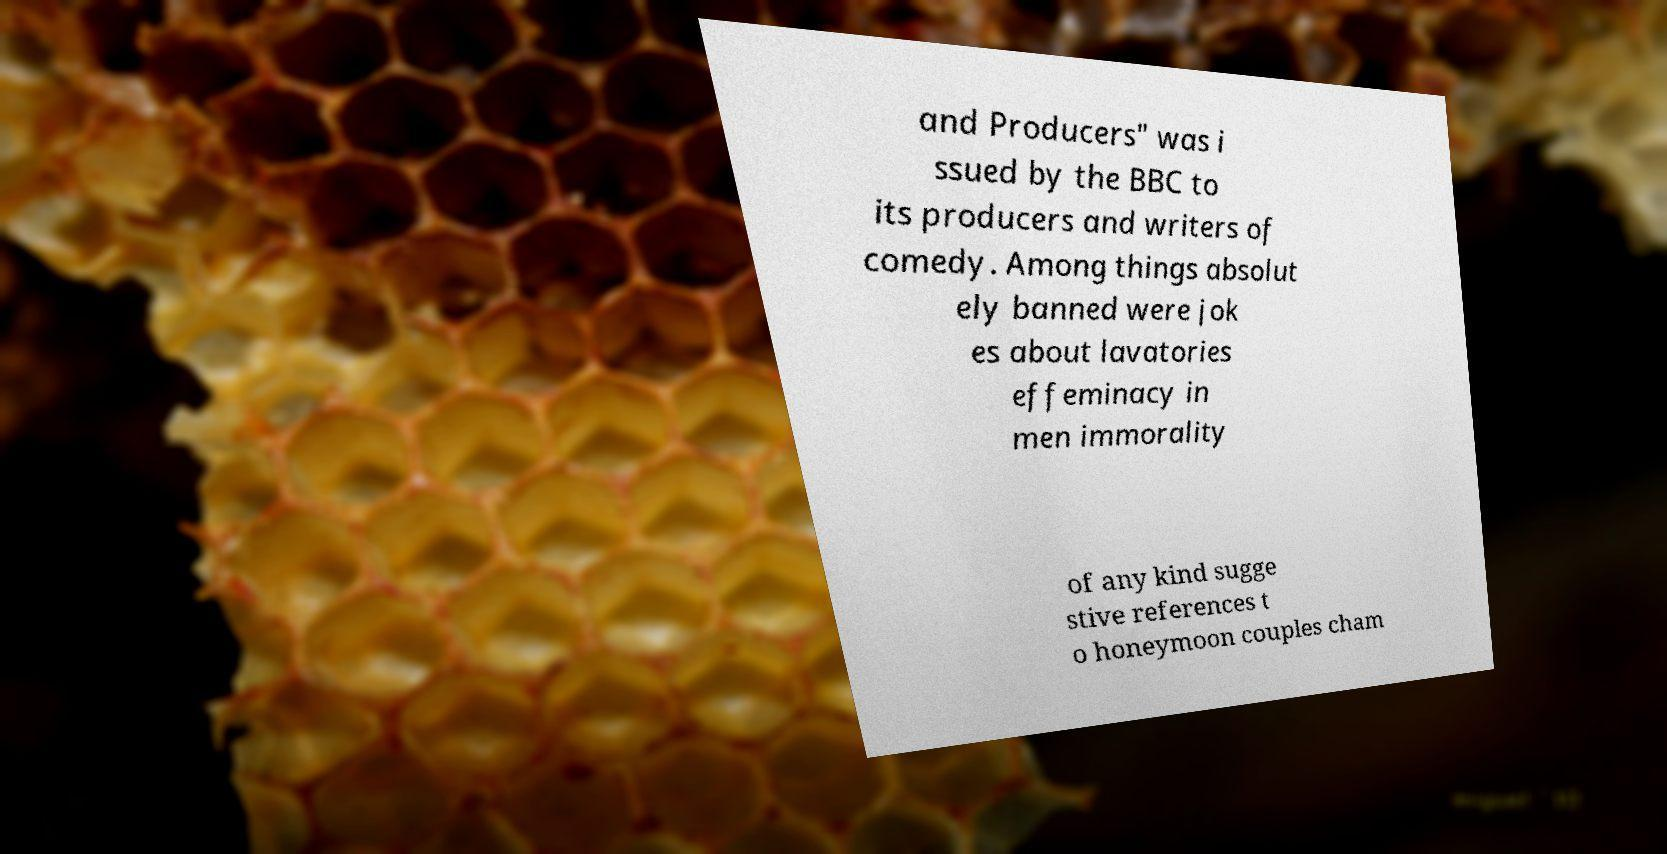Could you assist in decoding the text presented in this image and type it out clearly? and Producers" was i ssued by the BBC to its producers and writers of comedy. Among things absolut ely banned were jok es about lavatories effeminacy in men immorality of any kind sugge stive references t o honeymoon couples cham 